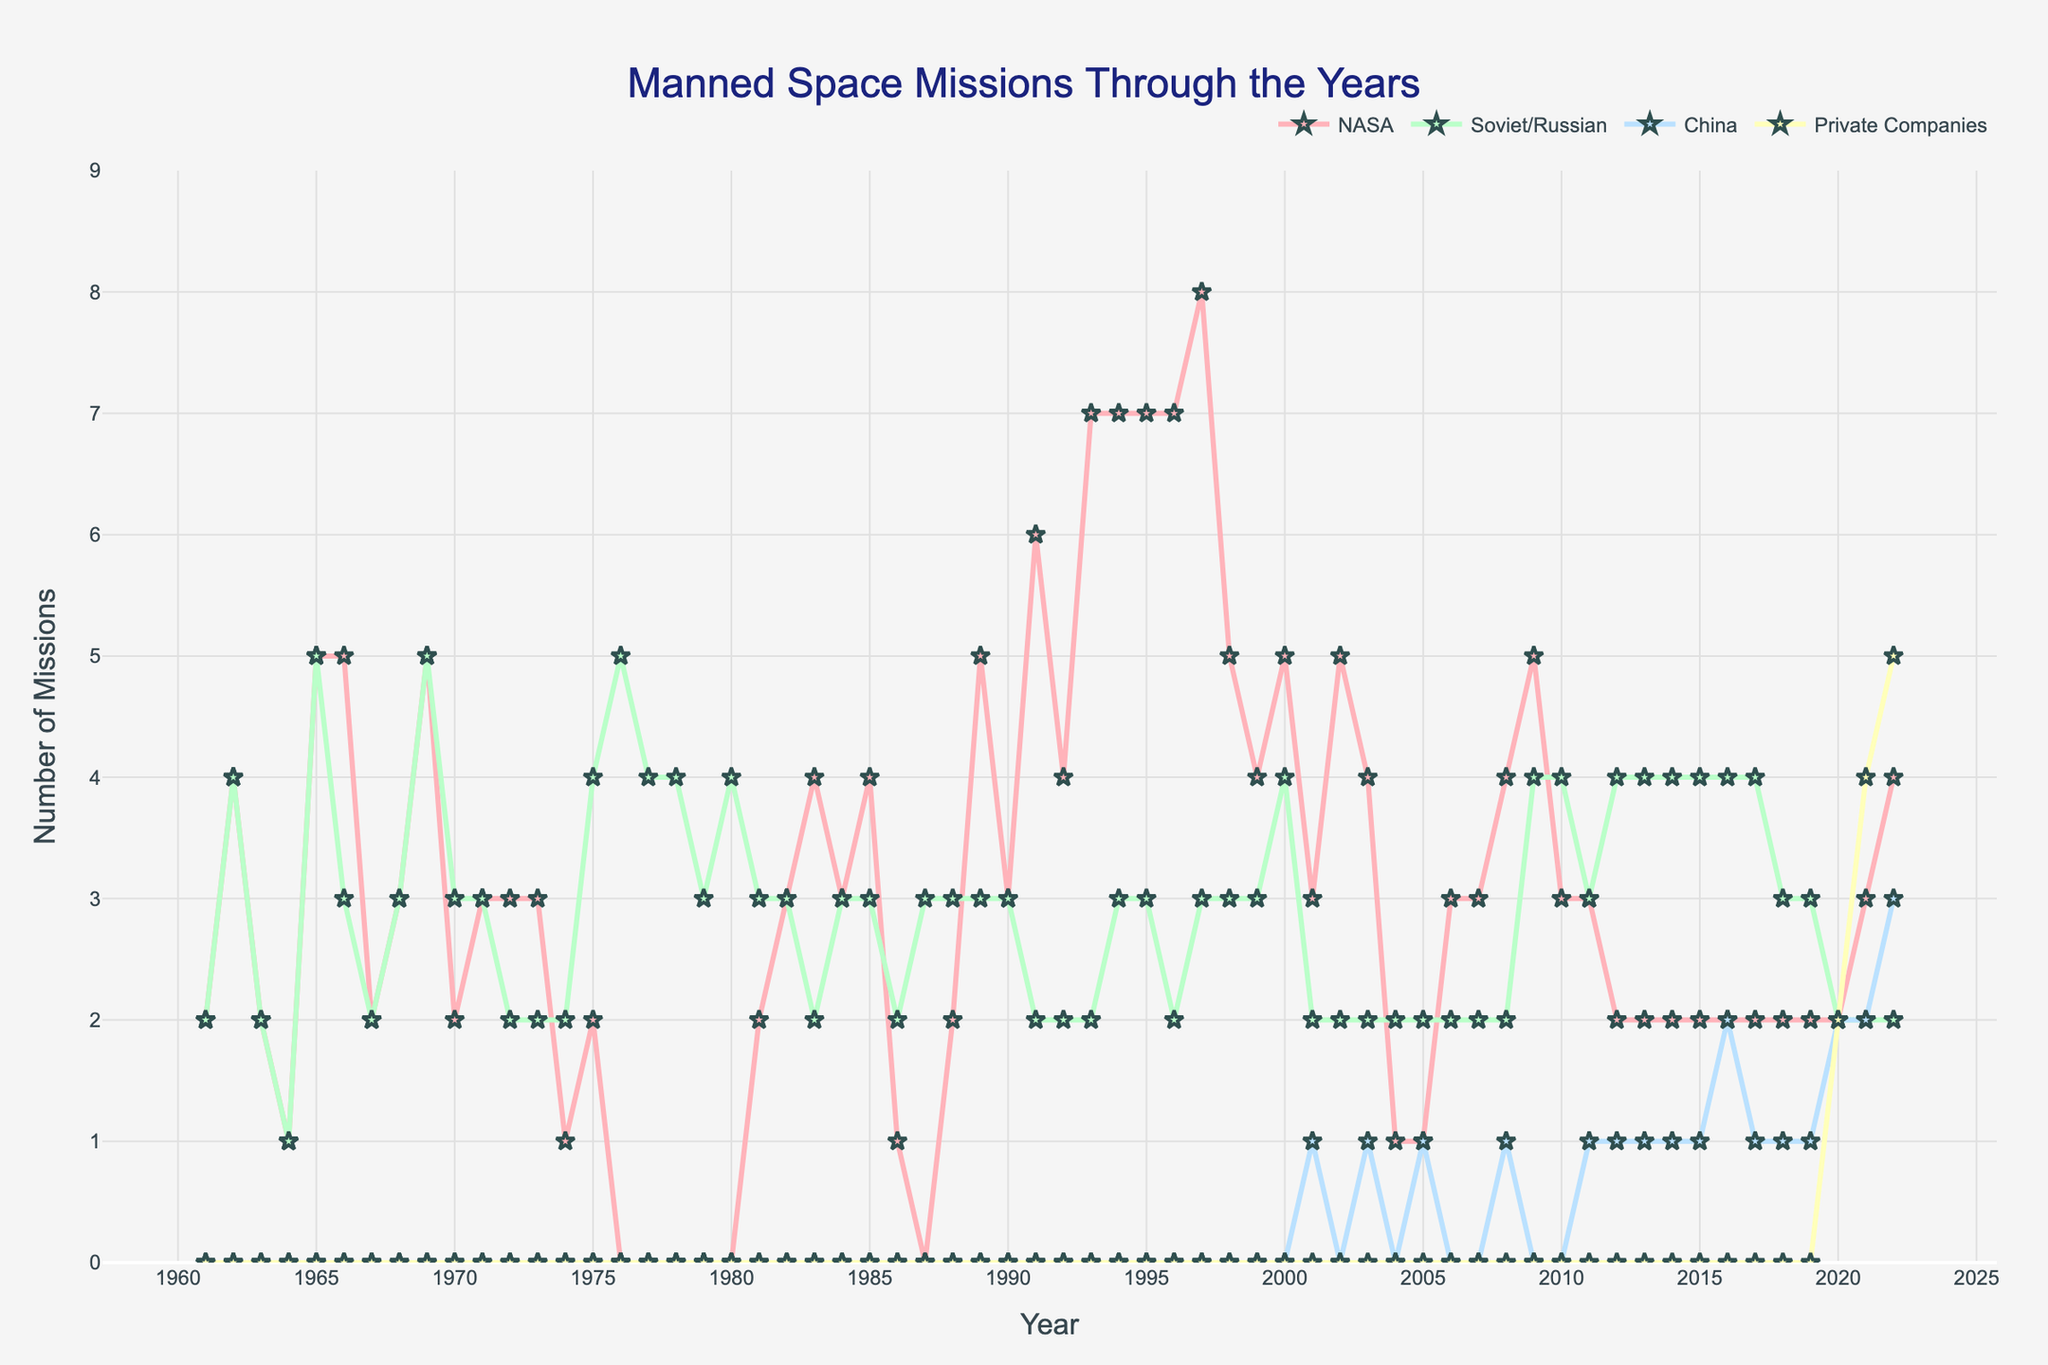What's the highest number of missions NASA conducted in a single year? Look for the peak in the NASA line on the chart. The highest number of missions NASA conducted in a single year was 8 in 1997.
Answer: 8 Which year had the most missions conducted by Soviet/Russian space agency? Identify the peak point on the Soviet/Russian line. The most missions by Soviet/Russian space agency were in 1976 with 5 missions.
Answer: 1976 During which period did private companies start conducting manned space missions? Identify the starting point of the line representing private companies. Private companies started conducting manned space missions in 2020.
Answer: 2020 In which year did the combined total of missions from NASA and Soviet/Russian space agency first reach 10? Sum the number of missions for NASA and Soviet/Russian for each year. The combined total first reached 10 in 1994 (NASA: 7, Soviet/Russian: 3).
Answer: 1994 How many years did NASA conduct more missions than Soviet/Russian space agency after 1980? Count the years where the NASA line is above the Soviet/Russian line post-1980. NASA conducted more missions in 15 years after 1980.
Answer: 15 Which country/agency had the most consistent number of missions over the years? Look for the line with the least fluctuation. Soviet/Russian space agency had the most consistent number of missions over the years.
Answer: Soviet/Russian What's the difference between the highest and lowest number of missions for China? Find the highest value and lowest value for China, then subtract. Highest: 3 (2022), Lowest: 0 (many years). The difference is 3 - 0 = 3.
Answer: 3 How many missions did private companies conduct in 2021? Check the value of the private companies line for the year 2021. Private companies conducted 4 missions in 2021.
Answer: 4 What is the average number of missions per year for NASA from 1990 to 2000? Sum the number of NASA missions from 1990 to 2000, then divide by the number of years. Total (31) / 11 years = 2.82.
Answer: 2.82 